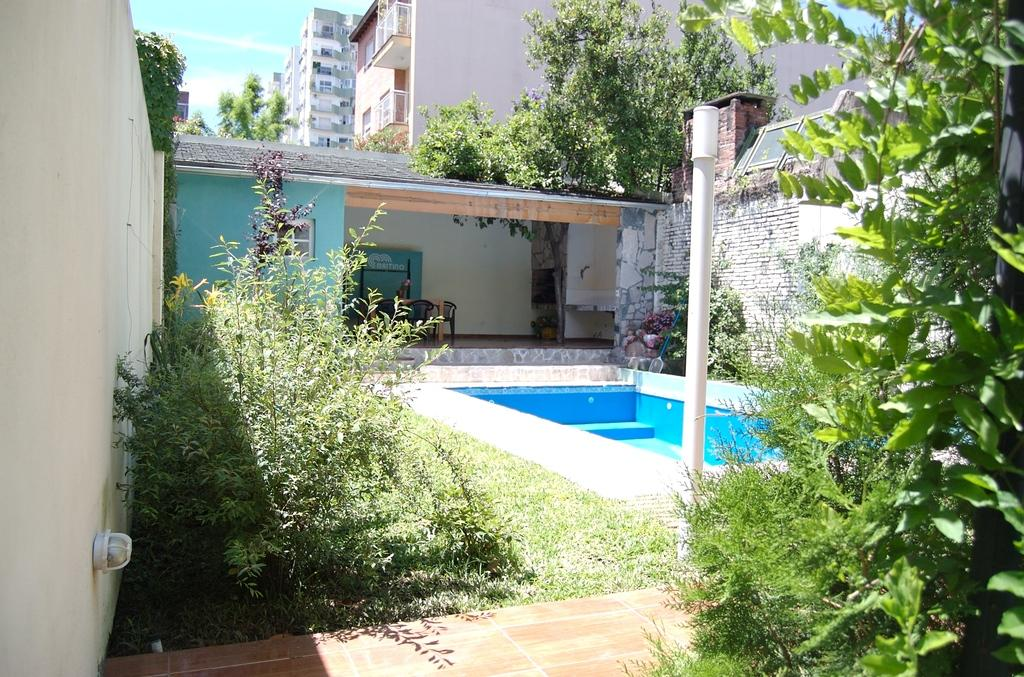What type of vegetation can be seen in the image? There are trees in the image. What structure is present in the image? There is a pole in the image. What type of construction is visible in the image? There are walls in the image. What type of ground surface is present in the image? There is grass in the image. What type of furniture is present in the image? There are chairs in the image. What type of building is visible in the image? There is a house with a window in the image. What type of structures are visible in the image? There are buildings in the image. What type of material is present in the image? There are stones in the image. What is visible in the background of the image? The sky is visible in the background of the image. What type of observation can be made from the art in the image? There is no art present in the image. --- Facts: 1. There is a car in the image. 12. The car has wheels. 13. The car has a windshield. 14. The car has doors. 15. The car has a trunk. 16. The car has a steering wheel. 17. The car has a dashboard. 18. The car has a seat. 19. The car has a roof. 120. The car has a hood. 121. The car has a bumper. 122. The car has a license plate. 123. The car has a rearview mirror. 124. The car has a side mirror. 125. The car has a gas tank. 126. The car has a brake pedal. 127. The car has an accelerator pedal. 128. The car has a gear shift. 129. The car has a radio. 130. The car has a glove compartment. 131. The car has a trunk lock. 132. The car has a keyhole. 133. The car has a fuel cap. 134. The car has a tailpipe. 135. The car has a catalytic converter. 136. The car has a muffler. 137. The car has a suspension system. 138. The car has a tire. 139. The car has a headlight. 140. The car has a taillight. 141. The car has a turn signal light. 142. The car has a brake light. 143. The car has a fog light. 144. The car has a high beam light. 145. The car has a low beam light. 146. The car has a reverse light. 147. The car has a side marker 